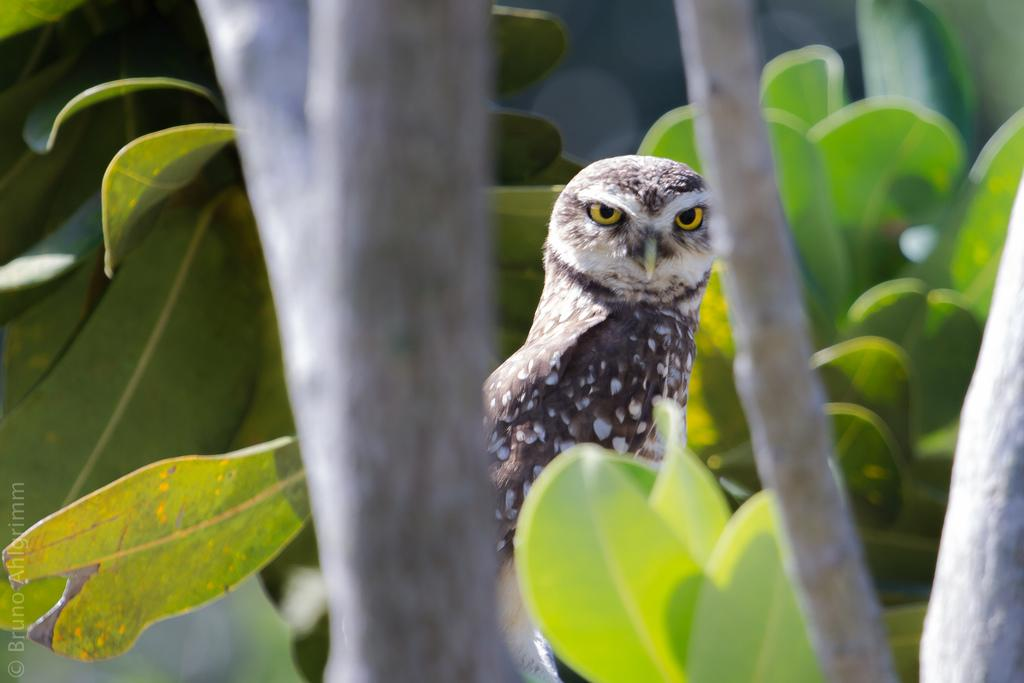What type of animal can be seen in the image? There is a bird in the image. Where is the bird located? The bird is on a tree. What type of secretary can be seen working in the image? There is no secretary present in the image; it features a bird on a tree. Can you tell me how many carts are visible in the image? There are no carts visible in the image; it features a bird on a tree. 